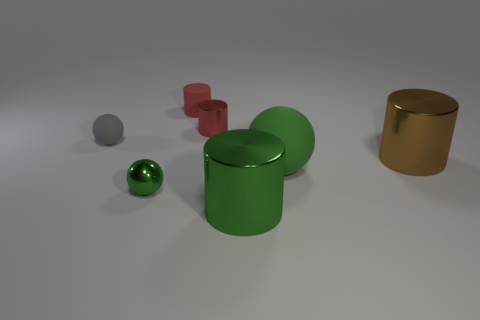Subtract all tiny matte cylinders. How many cylinders are left? 3 Subtract 2 cylinders. How many cylinders are left? 2 Subtract all green cylinders. How many cylinders are left? 3 Add 1 matte spheres. How many objects exist? 8 Subtract all blue cylinders. Subtract all green blocks. How many cylinders are left? 4 Subtract all cylinders. How many objects are left? 3 Add 7 tiny brown rubber cubes. How many tiny brown rubber cubes exist? 7 Subtract 0 purple cylinders. How many objects are left? 7 Subtract all yellow rubber balls. Subtract all big green rubber balls. How many objects are left? 6 Add 4 green rubber balls. How many green rubber balls are left? 5 